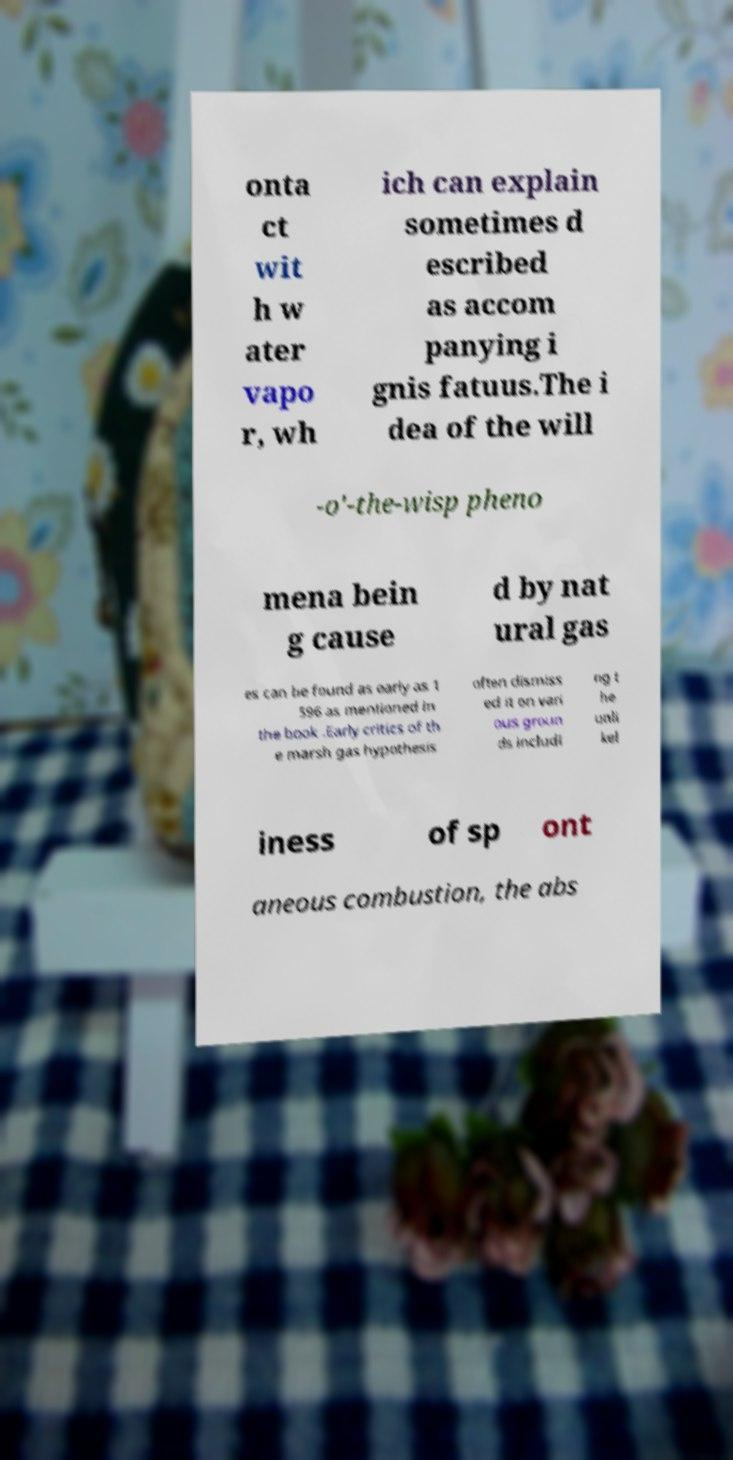There's text embedded in this image that I need extracted. Can you transcribe it verbatim? onta ct wit h w ater vapo r, wh ich can explain sometimes d escribed as accom panying i gnis fatuus.The i dea of the will -o'-the-wisp pheno mena bein g cause d by nat ural gas es can be found as early as 1 596 as mentioned in the book .Early critics of th e marsh gas hypothesis often dismiss ed it on vari ous groun ds includi ng t he unli kel iness of sp ont aneous combustion, the abs 